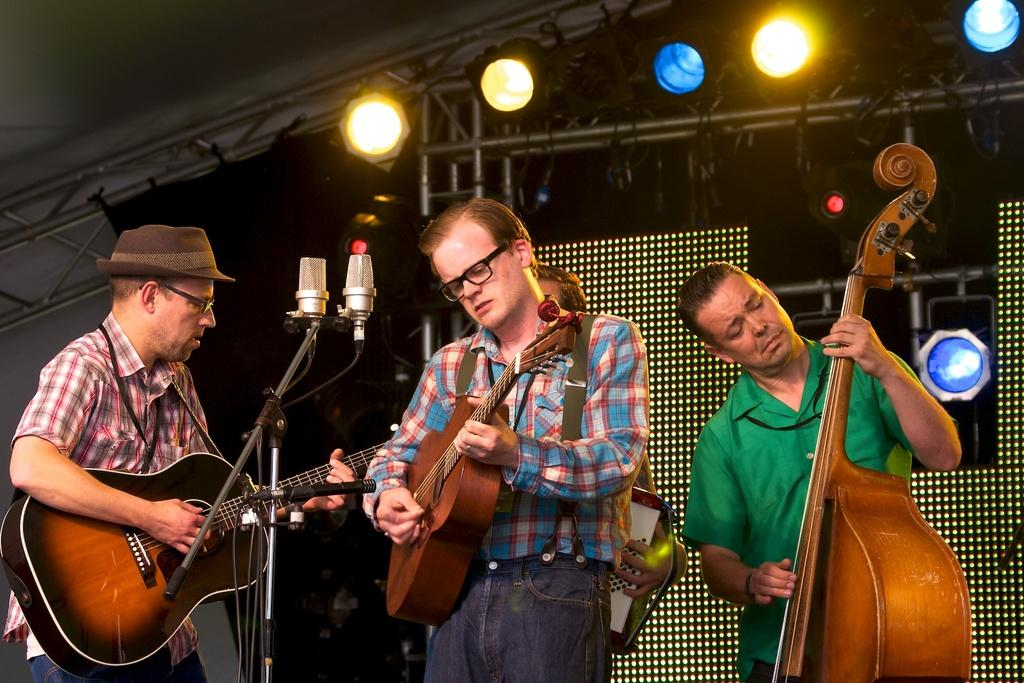How many people are in the image? There are four men in the image. What are the men doing in the image? Each man is holding a musical instrument. Where are the men standing in the image? The men are standing in front of a microphone. What can be seen in the background of the image? There are lights visible in the background of the image. What type of lock can be seen securing the microphone in the image? There is no lock visible in the image, and the microphone is not secured with a lock. 